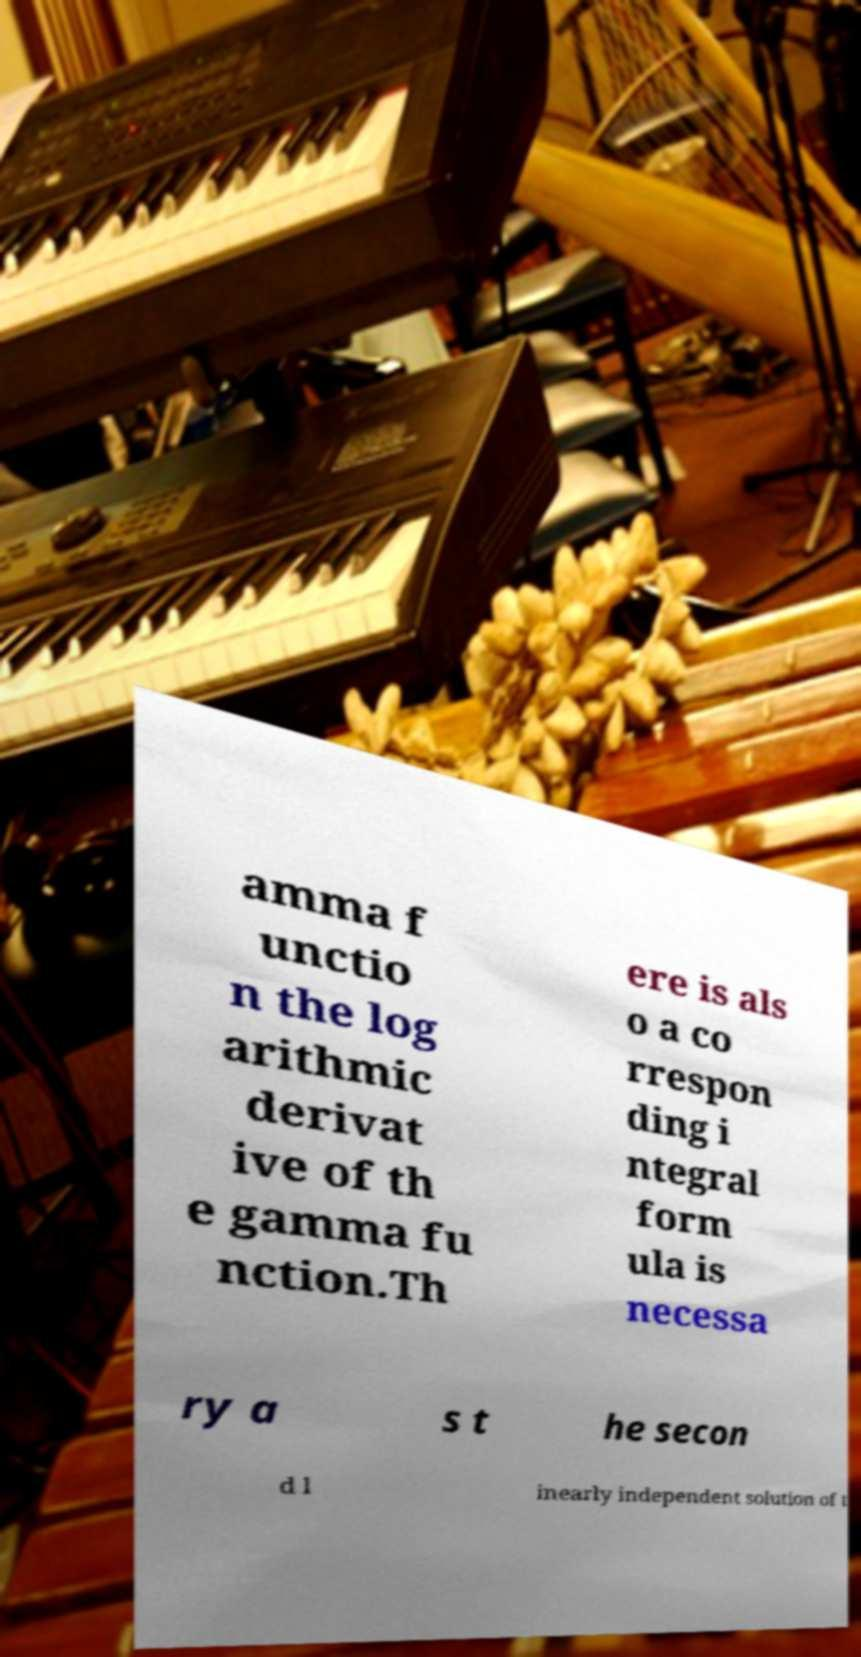Can you accurately transcribe the text from the provided image for me? amma f unctio n the log arithmic derivat ive of th e gamma fu nction.Th ere is als o a co rrespon ding i ntegral form ula is necessa ry a s t he secon d l inearly independent solution of t 